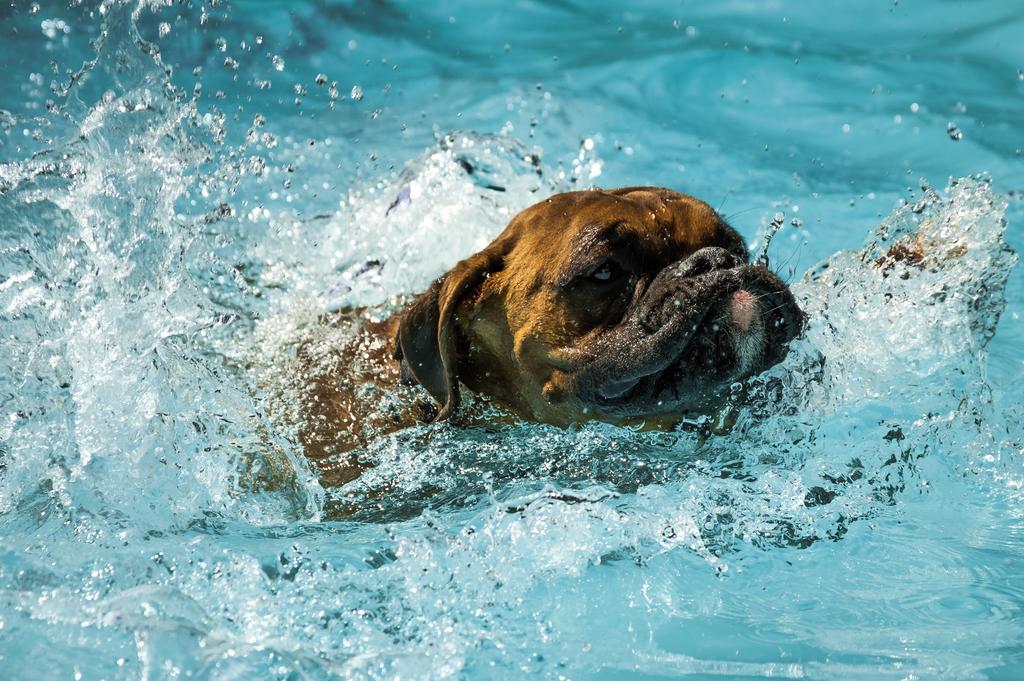Please provide a concise description of this image. In this image, we can see a dog in the water. 